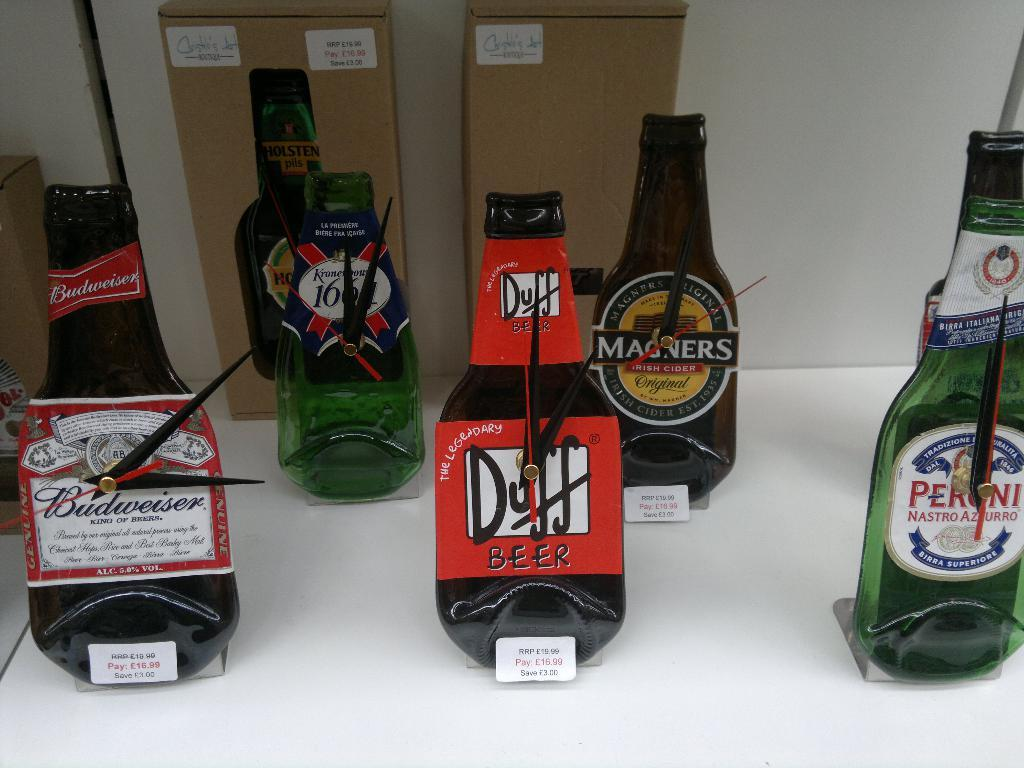Provide a one-sentence caption for the provided image. Flat beer bottles with the Duff Beer being in the middle. 